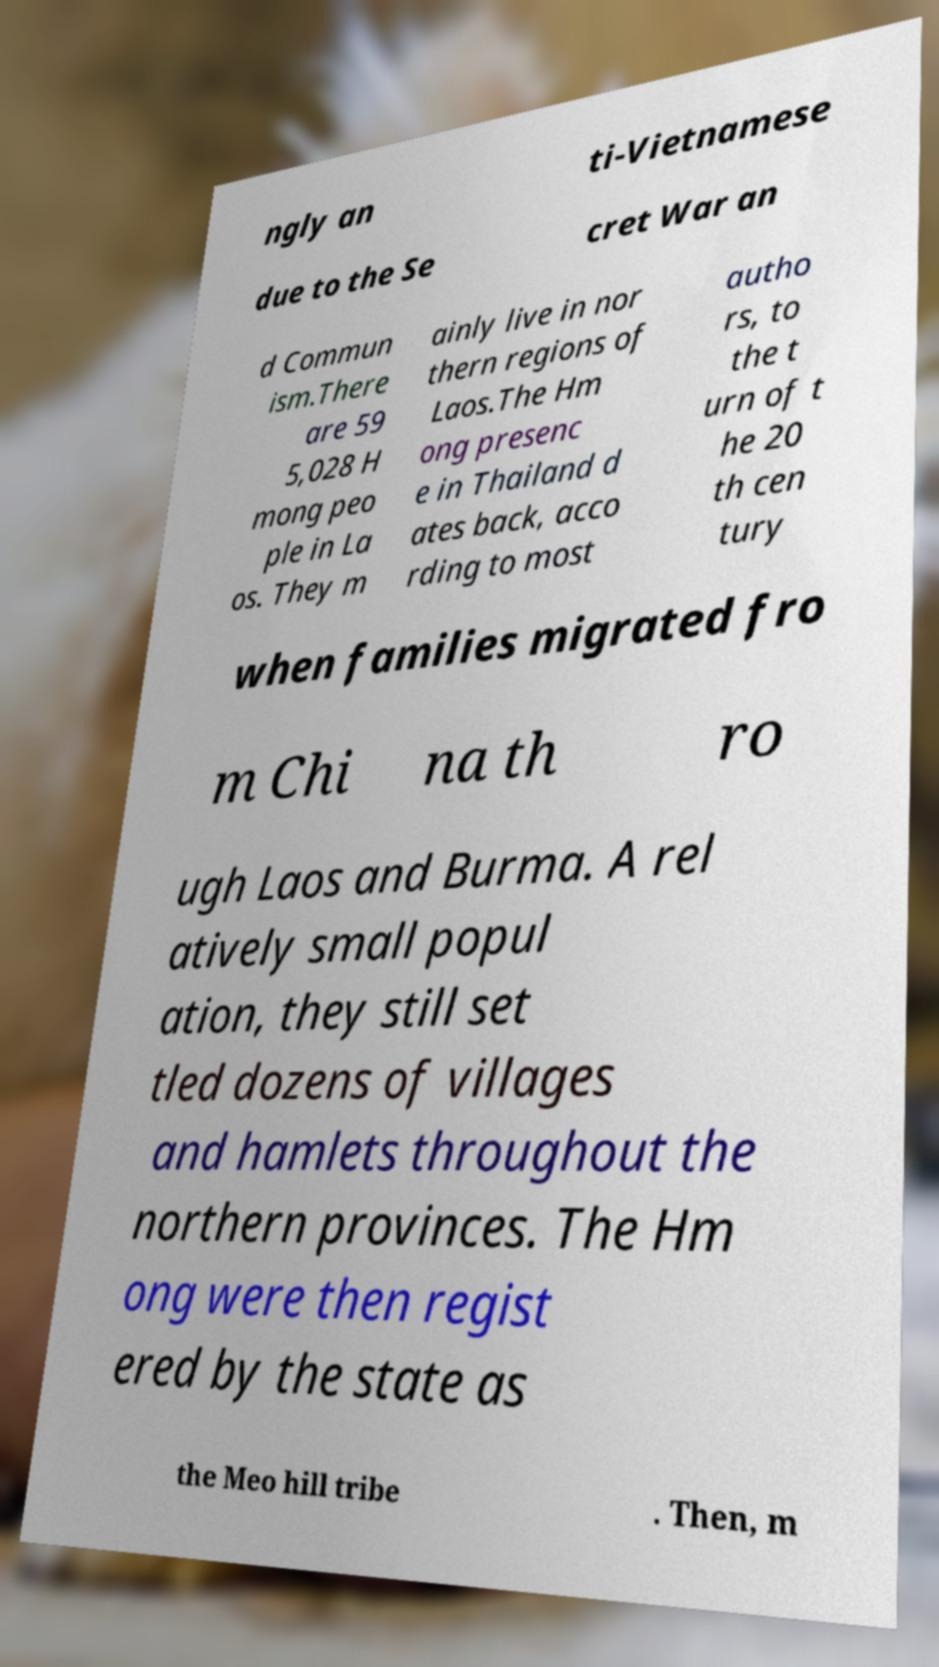There's text embedded in this image that I need extracted. Can you transcribe it verbatim? ngly an ti-Vietnamese due to the Se cret War an d Commun ism.There are 59 5,028 H mong peo ple in La os. They m ainly live in nor thern regions of Laos.The Hm ong presenc e in Thailand d ates back, acco rding to most autho rs, to the t urn of t he 20 th cen tury when families migrated fro m Chi na th ro ugh Laos and Burma. A rel atively small popul ation, they still set tled dozens of villages and hamlets throughout the northern provinces. The Hm ong were then regist ered by the state as the Meo hill tribe . Then, m 